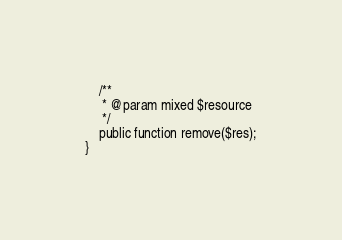<code> <loc_0><loc_0><loc_500><loc_500><_PHP_>    /**
     * @param mixed $resource
     */
    public function remove($res);
}
</code> 